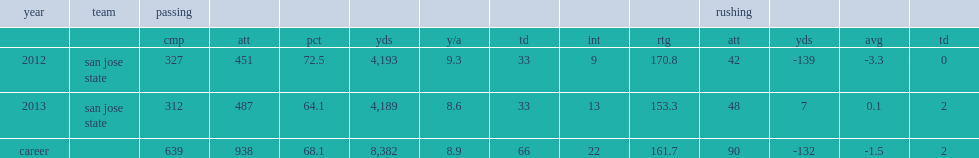How many completions did fales finish his san jose state records for career pass completions? 639.0. 